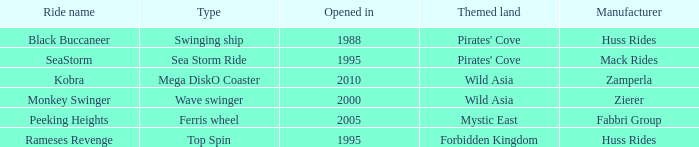Which attraction was produced by zierer? Monkey Swinger. 